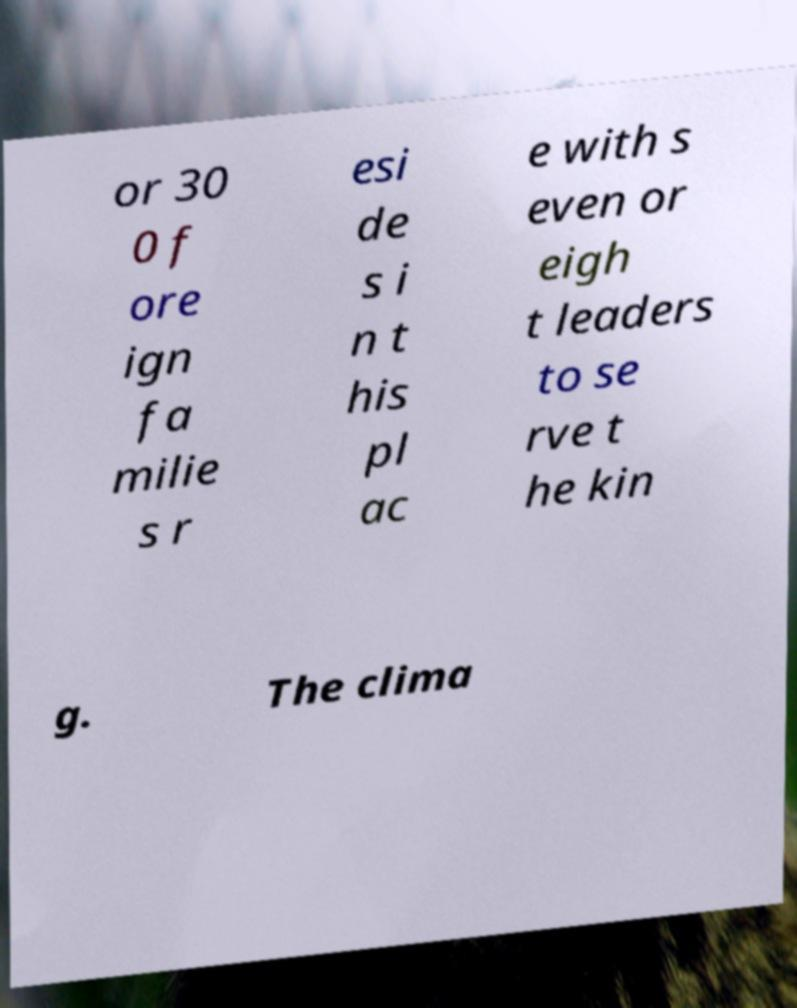There's text embedded in this image that I need extracted. Can you transcribe it verbatim? or 30 0 f ore ign fa milie s r esi de s i n t his pl ac e with s even or eigh t leaders to se rve t he kin g. The clima 